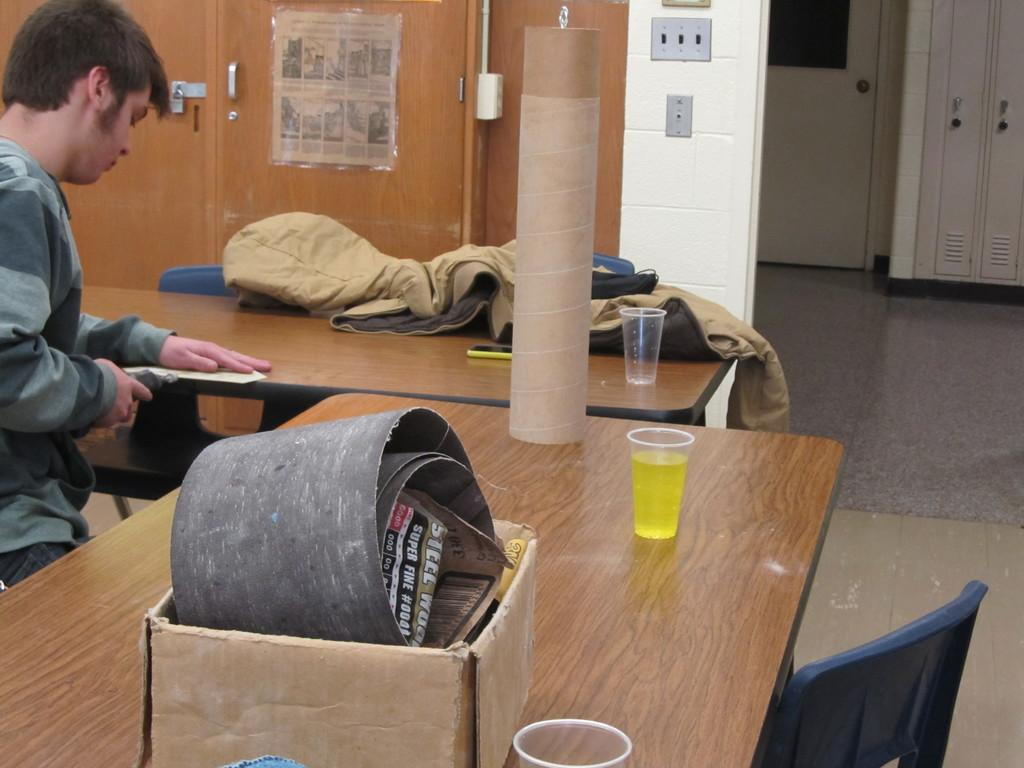Who or what is on the left side of the image? There is a person on the left side of the image. What is the person wearing? The person is wearing an ash-colored T-shirt. What can be seen in the middle of the image? There is a glass in the middle of the image. Where is the cardboard box located in the image? The cardboard box is on top of a table in the image. What type of aftermath can be seen in the image? There is no aftermath present in the image; it is a scene with a person, a glass, and a cardboard box. Can you spot a tiger in the image? No, there is no tiger present in the image. 